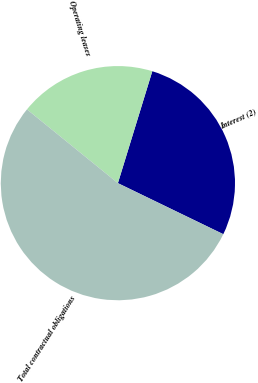Convert chart. <chart><loc_0><loc_0><loc_500><loc_500><pie_chart><fcel>Interest (2)<fcel>Operating leases<fcel>Total contractual obligations<nl><fcel>27.43%<fcel>18.9%<fcel>53.67%<nl></chart> 